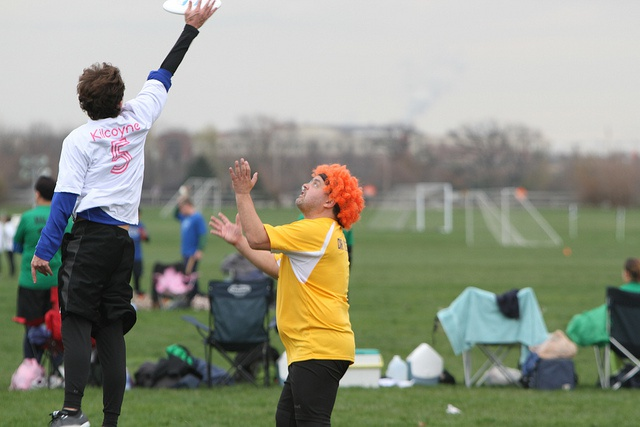Describe the objects in this image and their specific colors. I can see people in lightgray, black, lavender, navy, and gray tones, people in lightgray, orange, black, gold, and gray tones, chair in lightgray, lightblue, darkgray, and gray tones, people in lightgray, black, teal, and gray tones, and chair in lightgray, black, gray, and darkgreen tones in this image. 